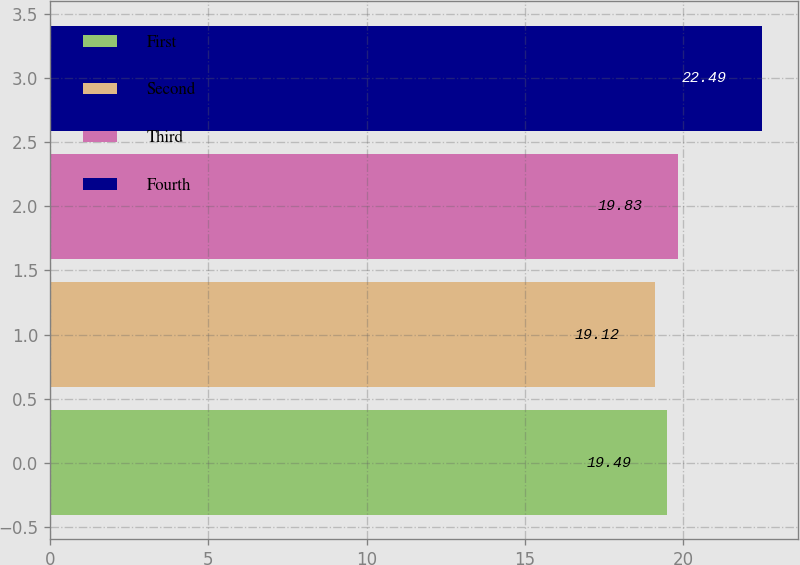<chart> <loc_0><loc_0><loc_500><loc_500><bar_chart><fcel>First<fcel>Second<fcel>Third<fcel>Fourth<nl><fcel>19.49<fcel>19.12<fcel>19.83<fcel>22.49<nl></chart> 